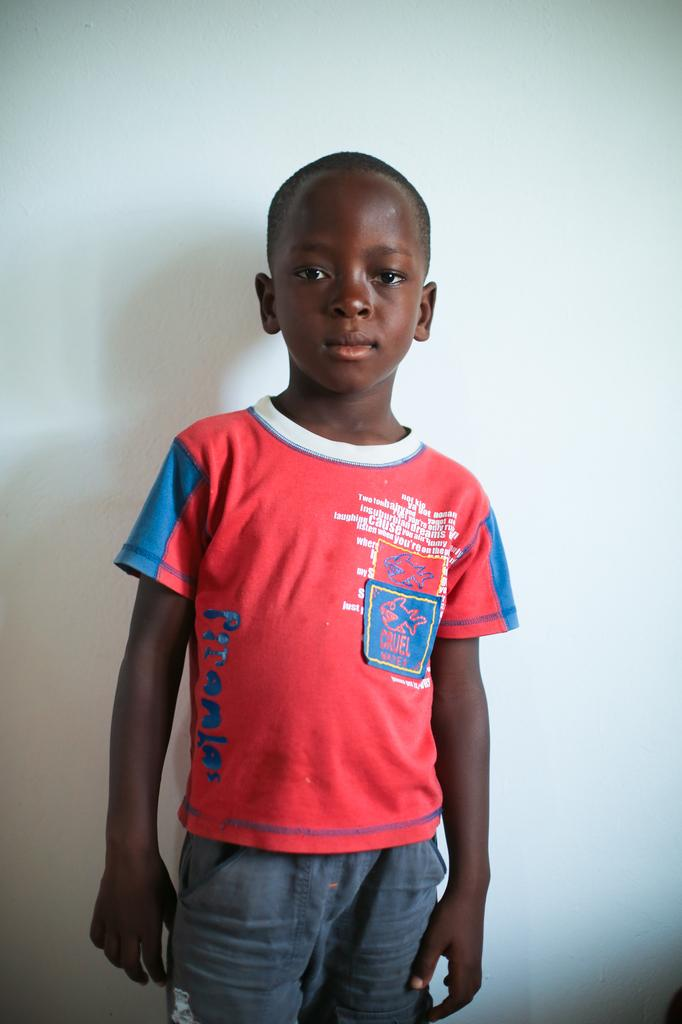What is the main subject of the image? The main subject of the image is a boy. What is the boy doing in the image? The boy is standing in the image. What can be seen in the background of the image? There is a wall in the background of the image. What type of skin can be seen on the boy's hands in the image? There is no specific detail about the boy's skin visible in the image. What type of poison is the boy holding in the image? There is no poison present in the image; the boy is simply standing. 